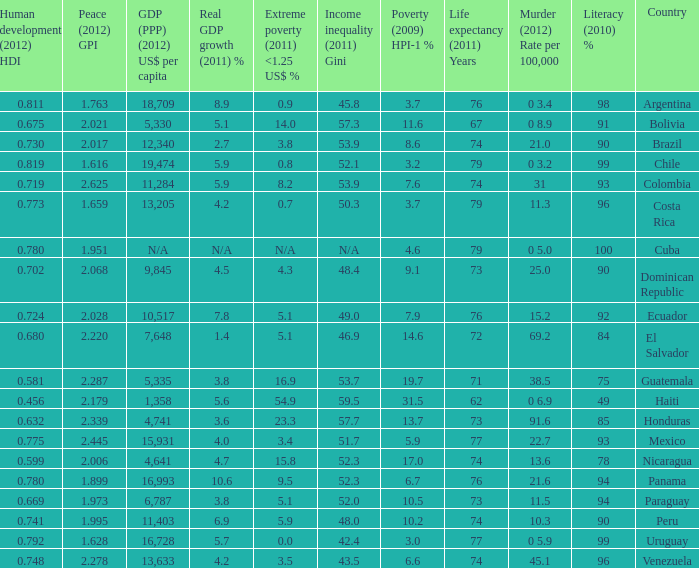What is the sum of poverty (2009) HPI-1 % when the GDP (PPP) (2012) US$ per capita of 11,284? 1.0. 